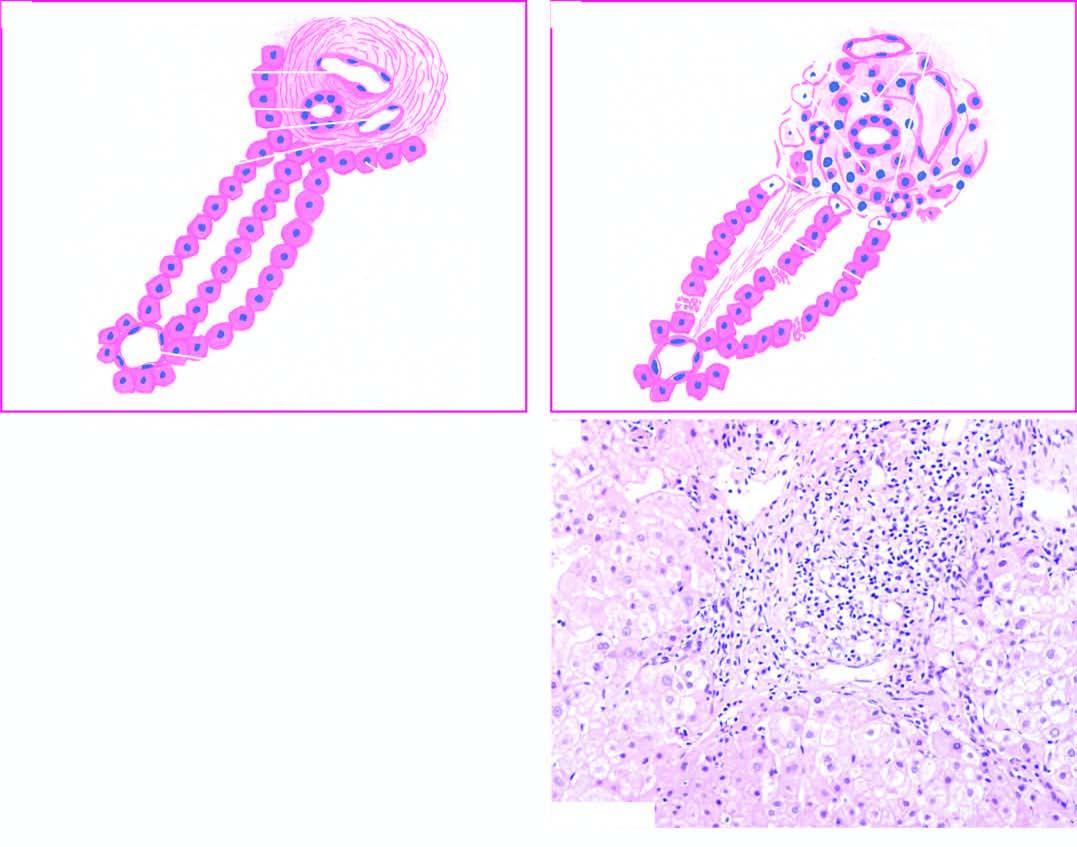re the mature red cells destroyed?
Answer the question using a single word or phrase. No 